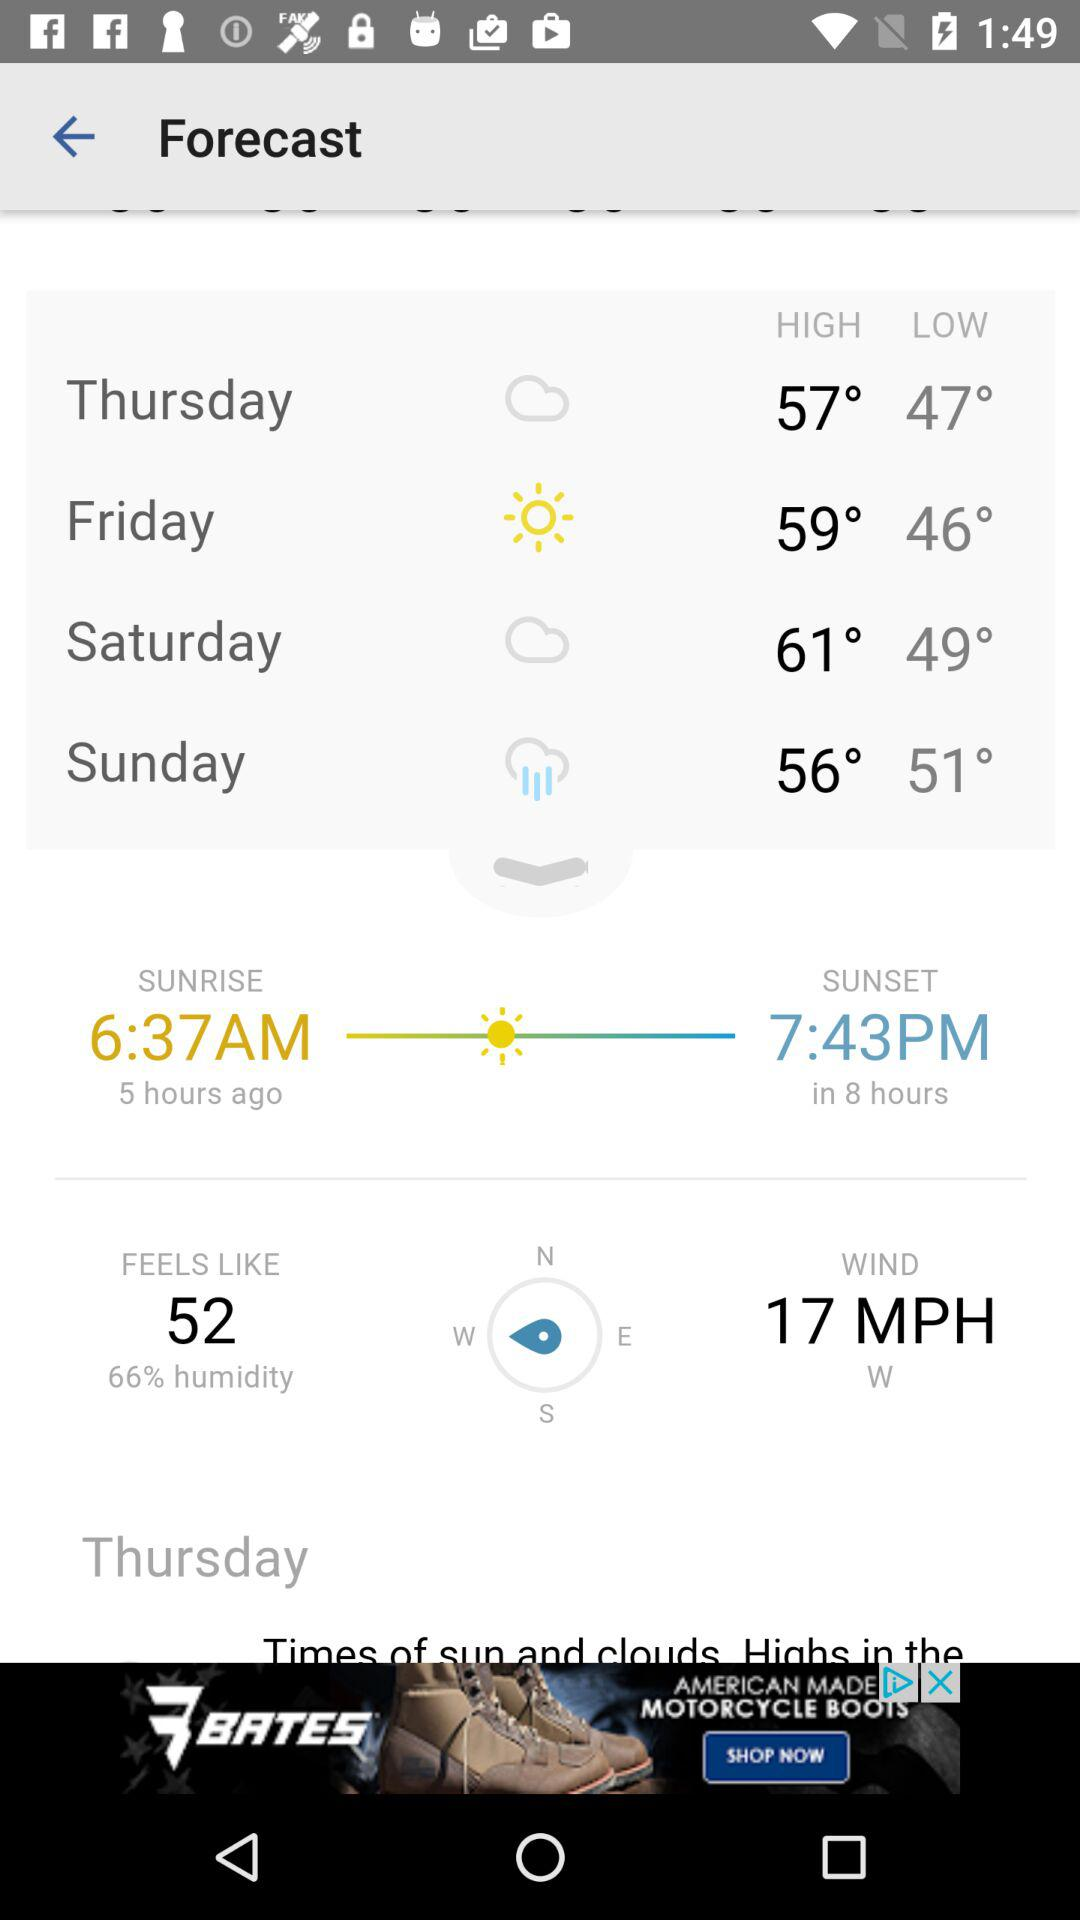What is the difference between the high and low temperatures for Friday?
Answer the question using a single word or phrase. 13° 